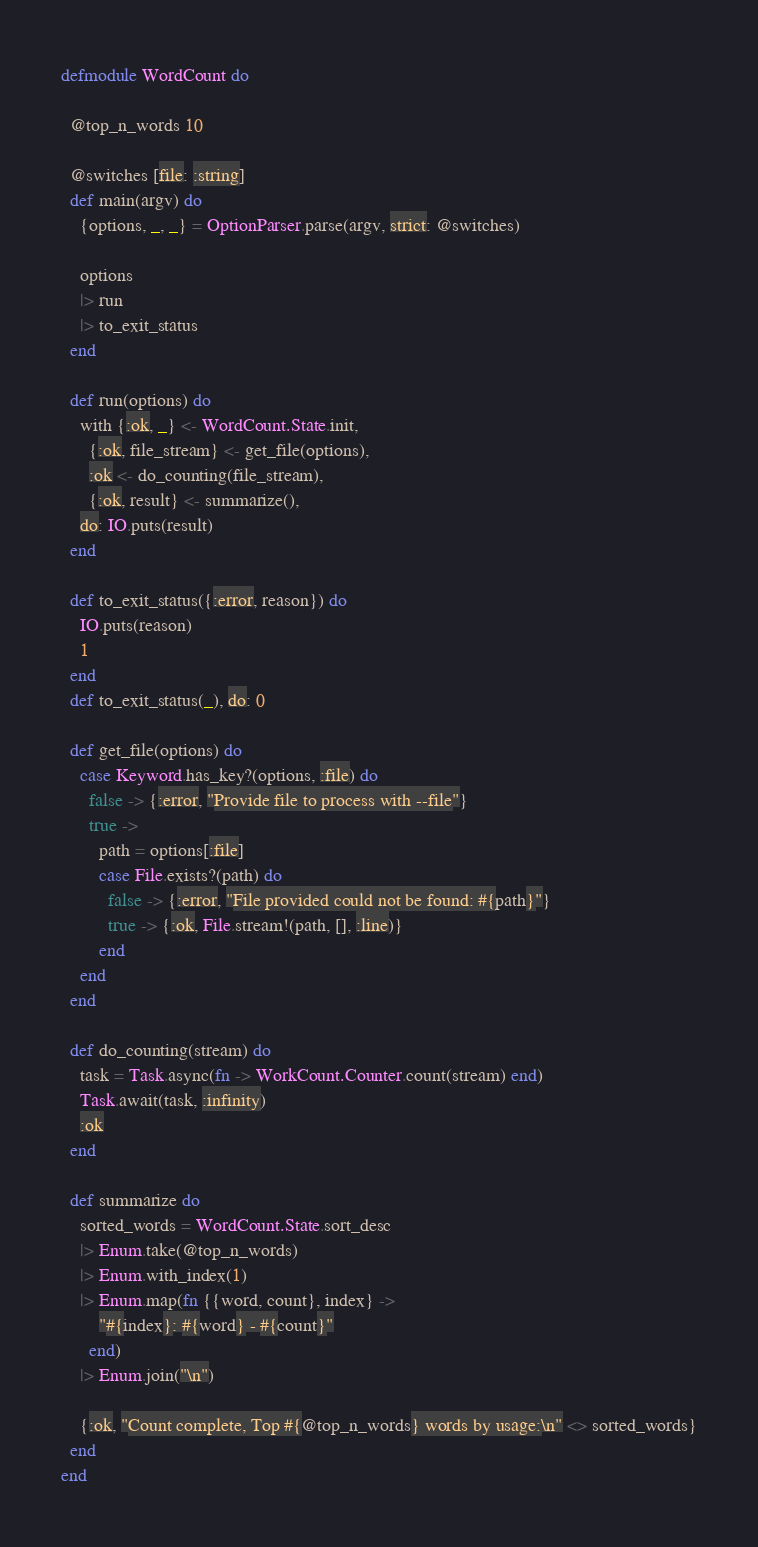<code> <loc_0><loc_0><loc_500><loc_500><_Elixir_>defmodule WordCount do

  @top_n_words 10

  @switches [file: :string]
  def main(argv) do
    {options, _, _} = OptionParser.parse(argv, strict: @switches)

    options
    |> run
    |> to_exit_status
  end

  def run(options) do
    with {:ok, _} <- WordCount.State.init,
      {:ok, file_stream} <- get_file(options),
      :ok <- do_counting(file_stream),
      {:ok, result} <- summarize(),
    do: IO.puts(result)
  end

  def to_exit_status({:error, reason}) do
    IO.puts(reason)
    1
  end
  def to_exit_status(_), do: 0

  def get_file(options) do
    case Keyword.has_key?(options, :file) do
      false -> {:error, "Provide file to process with --file"}
      true ->
        path = options[:file]
        case File.exists?(path) do
          false -> {:error, "File provided could not be found: #{path}"}
          true -> {:ok, File.stream!(path, [], :line)}
        end
    end
  end

  def do_counting(stream) do
    task = Task.async(fn -> WorkCount.Counter.count(stream) end)
    Task.await(task, :infinity)
    :ok
  end

  def summarize do
    sorted_words = WordCount.State.sort_desc
    |> Enum.take(@top_n_words)
    |> Enum.with_index(1)
    |> Enum.map(fn {{word, count}, index} ->
        "#{index}: #{word} - #{count}"
      end)
    |> Enum.join("\n")

    {:ok, "Count complete, Top #{@top_n_words} words by usage:\n" <> sorted_words}
  end
end
</code> 